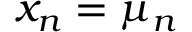Convert formula to latex. <formula><loc_0><loc_0><loc_500><loc_500>x _ { n } = \mu _ { n }</formula> 